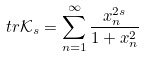<formula> <loc_0><loc_0><loc_500><loc_500>t r \mathcal { K } _ { s } = \sum _ { n = 1 } ^ { \infty } \frac { x _ { n } ^ { 2 s } } { 1 + x _ { n } ^ { 2 } }</formula> 